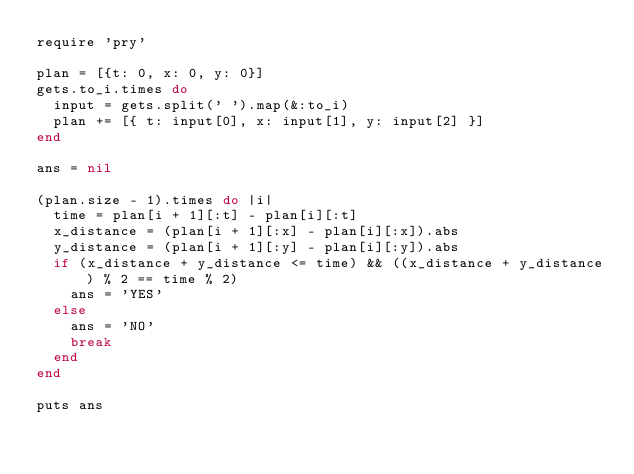Convert code to text. <code><loc_0><loc_0><loc_500><loc_500><_Ruby_>require 'pry'

plan = [{t: 0, x: 0, y: 0}]
gets.to_i.times do
  input = gets.split(' ').map(&:to_i)
  plan += [{ t: input[0], x: input[1], y: input[2] }]
end

ans = nil

(plan.size - 1).times do |i|
  time = plan[i + 1][:t] - plan[i][:t]
  x_distance = (plan[i + 1][:x] - plan[i][:x]).abs
  y_distance = (plan[i + 1][:y] - plan[i][:y]).abs
  if (x_distance + y_distance <= time) && ((x_distance + y_distance) % 2 == time % 2)
    ans = 'YES'
  else
    ans = 'NO'
    break
  end
end

puts ans
</code> 